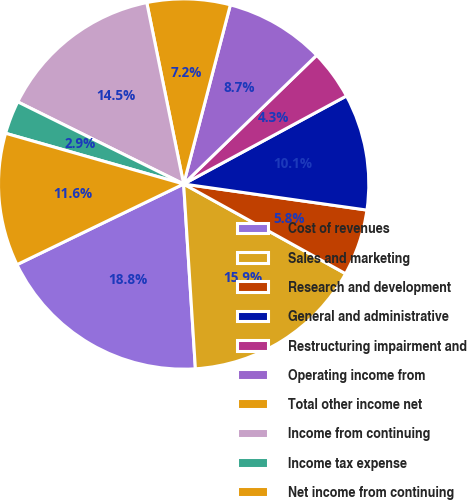Convert chart. <chart><loc_0><loc_0><loc_500><loc_500><pie_chart><fcel>Cost of revenues<fcel>Sales and marketing<fcel>Research and development<fcel>General and administrative<fcel>Restructuring impairment and<fcel>Operating income from<fcel>Total other income net<fcel>Income from continuing<fcel>Income tax expense<fcel>Net income from continuing<nl><fcel>18.84%<fcel>15.94%<fcel>5.8%<fcel>10.14%<fcel>4.35%<fcel>8.7%<fcel>7.25%<fcel>14.49%<fcel>2.9%<fcel>11.59%<nl></chart> 